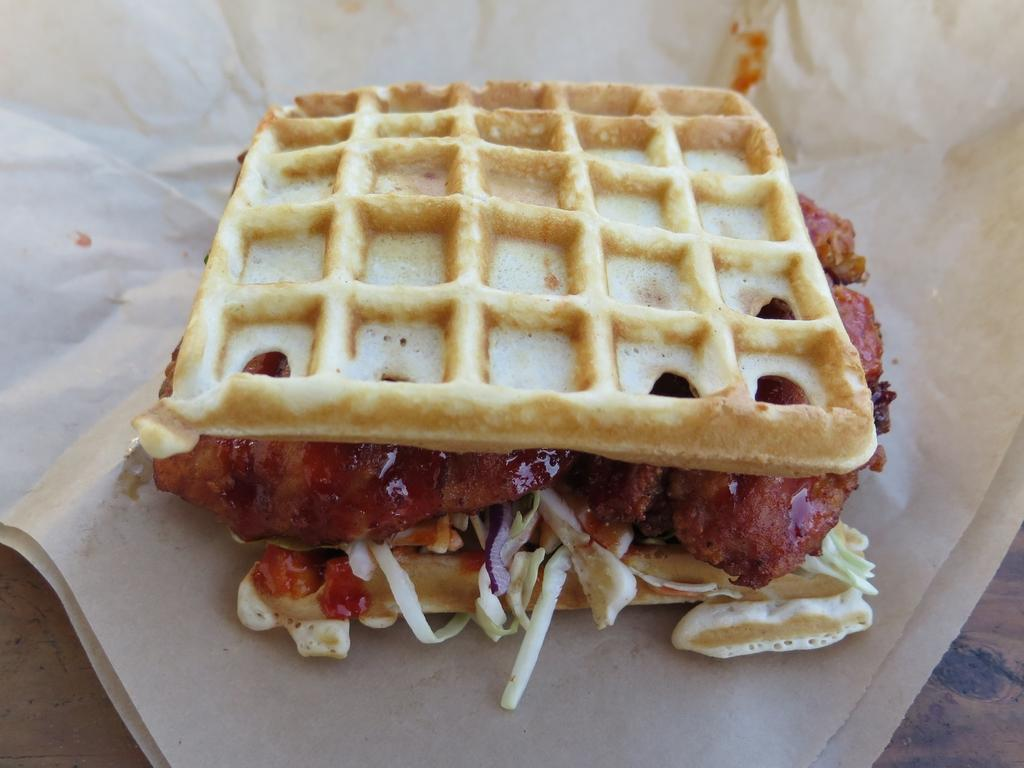What is the main subject of the image? There is a food item in the image. How is the food item presented in the image? The food item is wrapped in a white color tissue. What colors can be seen in the food item? The food has colors of white, cream, brown, and red. What historical event is depicted in the image? There is no historical event depicted in the image; it features a food item wrapped in a white color tissue. What type of pest can be seen crawling on the food item in the image? There are no pests present in the image; it only shows a food item wrapped in a white color tissue. 